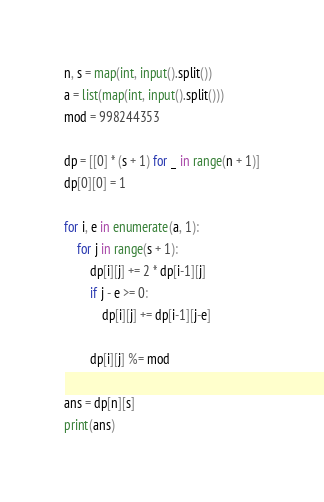Convert code to text. <code><loc_0><loc_0><loc_500><loc_500><_Python_>n, s = map(int, input().split())
a = list(map(int, input().split()))
mod = 998244353

dp = [[0] * (s + 1) for _ in range(n + 1)]
dp[0][0] = 1

for i, e in enumerate(a, 1):
    for j in range(s + 1):
        dp[i][j] += 2 * dp[i-1][j]
        if j - e >= 0:
            dp[i][j] += dp[i-1][j-e]

        dp[i][j] %= mod

ans = dp[n][s]
print(ans)

</code> 